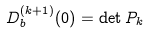<formula> <loc_0><loc_0><loc_500><loc_500>D _ { b } ^ { ( k + 1 ) } ( 0 ) = \det P _ { k }</formula> 